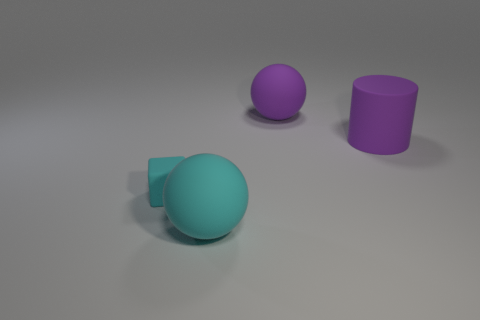Add 3 rubber blocks. How many objects exist? 7 Subtract all cylinders. How many objects are left? 3 Add 4 matte blocks. How many matte blocks exist? 5 Subtract 0 blue cylinders. How many objects are left? 4 Subtract all small brown rubber balls. Subtract all large cyan objects. How many objects are left? 3 Add 1 big purple rubber cylinders. How many big purple rubber cylinders are left? 2 